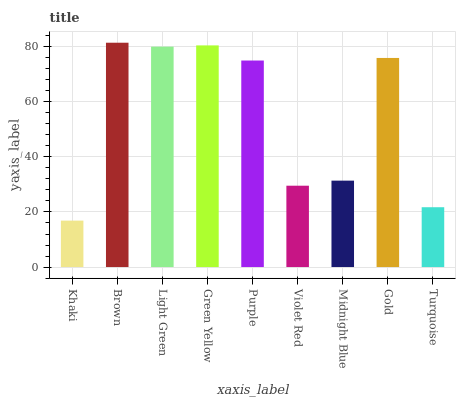Is Light Green the minimum?
Answer yes or no. No. Is Light Green the maximum?
Answer yes or no. No. Is Brown greater than Light Green?
Answer yes or no. Yes. Is Light Green less than Brown?
Answer yes or no. Yes. Is Light Green greater than Brown?
Answer yes or no. No. Is Brown less than Light Green?
Answer yes or no. No. Is Purple the high median?
Answer yes or no. Yes. Is Purple the low median?
Answer yes or no. Yes. Is Green Yellow the high median?
Answer yes or no. No. Is Light Green the low median?
Answer yes or no. No. 